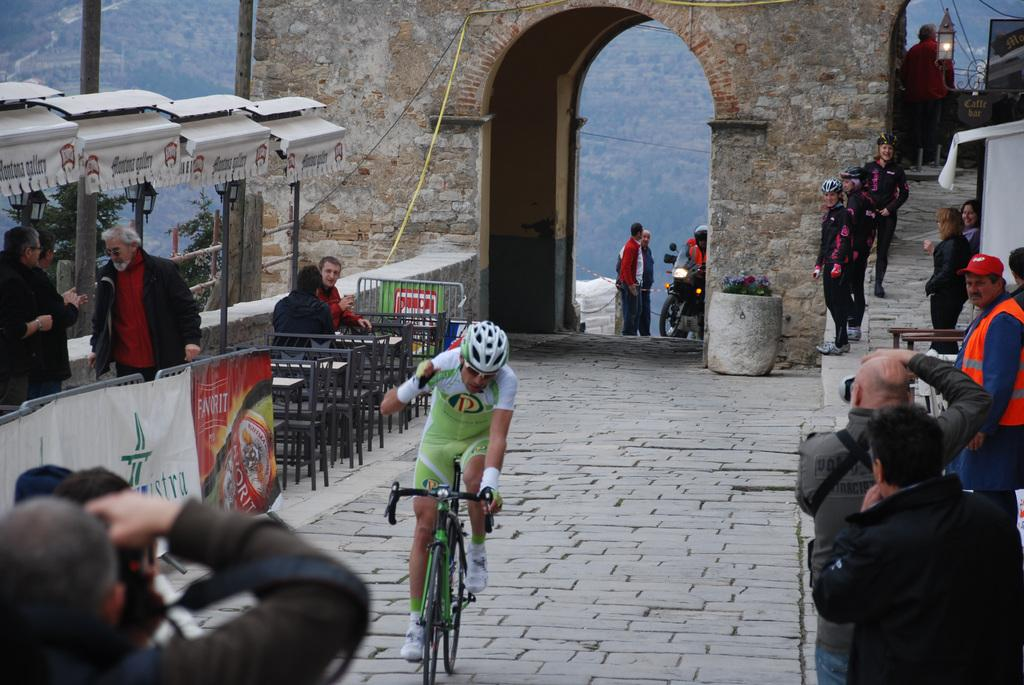What is the main subject of the image? The main subject of the image is a guy riding a bicycle. What is the guy wearing in the image? The guy is wearing a uniform and a helmet. What can be seen in the background of the image? There are spectators and a camera man in the background of the image. What is the camera man doing in the image? The camera man is clicking pictures. Can you tell me how many flowers are present in the image? There are no flowers visible in the image. What type of hill can be seen in the background of the image? There is no hill present in the image; it features a guy riding a bicycle with spectators and a camera man in the background. 